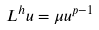<formula> <loc_0><loc_0><loc_500><loc_500>L ^ { h } u = \mu u ^ { p - 1 }</formula> 